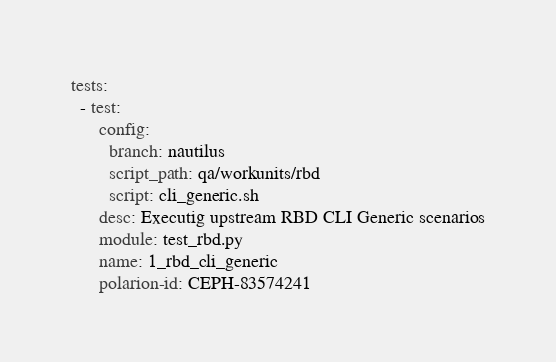<code> <loc_0><loc_0><loc_500><loc_500><_YAML_>tests:
  - test:
      config:
        branch: nautilus
        script_path: qa/workunits/rbd
        script: cli_generic.sh
      desc: Executig upstream RBD CLI Generic scenarios
      module: test_rbd.py
      name: 1_rbd_cli_generic
      polarion-id: CEPH-83574241
</code> 